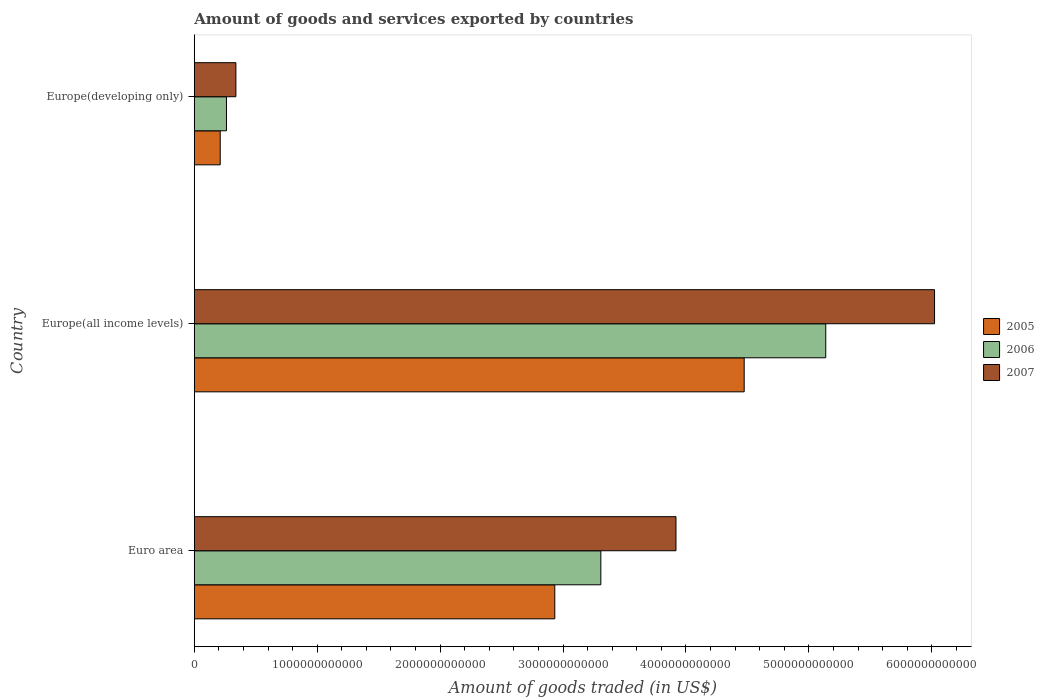How many different coloured bars are there?
Offer a very short reply. 3. In how many cases, is the number of bars for a given country not equal to the number of legend labels?
Offer a very short reply. 0. What is the total amount of goods and services exported in 2005 in Euro area?
Offer a very short reply. 2.93e+12. Across all countries, what is the maximum total amount of goods and services exported in 2006?
Give a very brief answer. 5.14e+12. Across all countries, what is the minimum total amount of goods and services exported in 2007?
Keep it short and to the point. 3.39e+11. In which country was the total amount of goods and services exported in 2007 maximum?
Your response must be concise. Europe(all income levels). In which country was the total amount of goods and services exported in 2005 minimum?
Provide a succinct answer. Europe(developing only). What is the total total amount of goods and services exported in 2007 in the graph?
Give a very brief answer. 1.03e+13. What is the difference between the total amount of goods and services exported in 2005 in Euro area and that in Europe(all income levels)?
Offer a terse response. -1.54e+12. What is the difference between the total amount of goods and services exported in 2006 in Euro area and the total amount of goods and services exported in 2007 in Europe(developing only)?
Your response must be concise. 2.97e+12. What is the average total amount of goods and services exported in 2007 per country?
Offer a very short reply. 3.43e+12. What is the difference between the total amount of goods and services exported in 2006 and total amount of goods and services exported in 2007 in Euro area?
Your response must be concise. -6.11e+11. What is the ratio of the total amount of goods and services exported in 2006 in Euro area to that in Europe(developing only)?
Keep it short and to the point. 12.62. Is the difference between the total amount of goods and services exported in 2006 in Euro area and Europe(developing only) greater than the difference between the total amount of goods and services exported in 2007 in Euro area and Europe(developing only)?
Keep it short and to the point. No. What is the difference between the highest and the second highest total amount of goods and services exported in 2006?
Offer a terse response. 1.83e+12. What is the difference between the highest and the lowest total amount of goods and services exported in 2005?
Your answer should be very brief. 4.26e+12. Is the sum of the total amount of goods and services exported in 2005 in Euro area and Europe(developing only) greater than the maximum total amount of goods and services exported in 2006 across all countries?
Offer a very short reply. No. What does the 3rd bar from the bottom in Euro area represents?
Your answer should be very brief. 2007. Is it the case that in every country, the sum of the total amount of goods and services exported in 2005 and total amount of goods and services exported in 2007 is greater than the total amount of goods and services exported in 2006?
Your answer should be compact. Yes. Are all the bars in the graph horizontal?
Your answer should be compact. Yes. What is the difference between two consecutive major ticks on the X-axis?
Make the answer very short. 1.00e+12. Are the values on the major ticks of X-axis written in scientific E-notation?
Your answer should be very brief. No. Does the graph contain any zero values?
Make the answer very short. No. What is the title of the graph?
Provide a short and direct response. Amount of goods and services exported by countries. What is the label or title of the X-axis?
Keep it short and to the point. Amount of goods traded (in US$). What is the label or title of the Y-axis?
Offer a very short reply. Country. What is the Amount of goods traded (in US$) of 2005 in Euro area?
Your response must be concise. 2.93e+12. What is the Amount of goods traded (in US$) of 2006 in Euro area?
Offer a terse response. 3.31e+12. What is the Amount of goods traded (in US$) of 2007 in Euro area?
Ensure brevity in your answer.  3.92e+12. What is the Amount of goods traded (in US$) of 2005 in Europe(all income levels)?
Ensure brevity in your answer.  4.47e+12. What is the Amount of goods traded (in US$) of 2006 in Europe(all income levels)?
Provide a short and direct response. 5.14e+12. What is the Amount of goods traded (in US$) in 2007 in Europe(all income levels)?
Make the answer very short. 6.02e+12. What is the Amount of goods traded (in US$) in 2005 in Europe(developing only)?
Your answer should be compact. 2.11e+11. What is the Amount of goods traded (in US$) of 2006 in Europe(developing only)?
Keep it short and to the point. 2.62e+11. What is the Amount of goods traded (in US$) of 2007 in Europe(developing only)?
Provide a short and direct response. 3.39e+11. Across all countries, what is the maximum Amount of goods traded (in US$) in 2005?
Make the answer very short. 4.47e+12. Across all countries, what is the maximum Amount of goods traded (in US$) of 2006?
Provide a succinct answer. 5.14e+12. Across all countries, what is the maximum Amount of goods traded (in US$) of 2007?
Your answer should be compact. 6.02e+12. Across all countries, what is the minimum Amount of goods traded (in US$) of 2005?
Your response must be concise. 2.11e+11. Across all countries, what is the minimum Amount of goods traded (in US$) of 2006?
Ensure brevity in your answer.  2.62e+11. Across all countries, what is the minimum Amount of goods traded (in US$) in 2007?
Your answer should be very brief. 3.39e+11. What is the total Amount of goods traded (in US$) of 2005 in the graph?
Provide a succinct answer. 7.62e+12. What is the total Amount of goods traded (in US$) in 2006 in the graph?
Keep it short and to the point. 8.71e+12. What is the total Amount of goods traded (in US$) in 2007 in the graph?
Keep it short and to the point. 1.03e+13. What is the difference between the Amount of goods traded (in US$) in 2005 in Euro area and that in Europe(all income levels)?
Your answer should be compact. -1.54e+12. What is the difference between the Amount of goods traded (in US$) of 2006 in Euro area and that in Europe(all income levels)?
Your answer should be very brief. -1.83e+12. What is the difference between the Amount of goods traded (in US$) of 2007 in Euro area and that in Europe(all income levels)?
Offer a very short reply. -2.10e+12. What is the difference between the Amount of goods traded (in US$) of 2005 in Euro area and that in Europe(developing only)?
Provide a succinct answer. 2.72e+12. What is the difference between the Amount of goods traded (in US$) of 2006 in Euro area and that in Europe(developing only)?
Make the answer very short. 3.05e+12. What is the difference between the Amount of goods traded (in US$) in 2007 in Euro area and that in Europe(developing only)?
Offer a very short reply. 3.58e+12. What is the difference between the Amount of goods traded (in US$) of 2005 in Europe(all income levels) and that in Europe(developing only)?
Offer a terse response. 4.26e+12. What is the difference between the Amount of goods traded (in US$) in 2006 in Europe(all income levels) and that in Europe(developing only)?
Make the answer very short. 4.88e+12. What is the difference between the Amount of goods traded (in US$) of 2007 in Europe(all income levels) and that in Europe(developing only)?
Provide a succinct answer. 5.68e+12. What is the difference between the Amount of goods traded (in US$) of 2005 in Euro area and the Amount of goods traded (in US$) of 2006 in Europe(all income levels)?
Your answer should be very brief. -2.20e+12. What is the difference between the Amount of goods traded (in US$) of 2005 in Euro area and the Amount of goods traded (in US$) of 2007 in Europe(all income levels)?
Provide a succinct answer. -3.09e+12. What is the difference between the Amount of goods traded (in US$) of 2006 in Euro area and the Amount of goods traded (in US$) of 2007 in Europe(all income levels)?
Keep it short and to the point. -2.71e+12. What is the difference between the Amount of goods traded (in US$) in 2005 in Euro area and the Amount of goods traded (in US$) in 2006 in Europe(developing only)?
Ensure brevity in your answer.  2.67e+12. What is the difference between the Amount of goods traded (in US$) of 2005 in Euro area and the Amount of goods traded (in US$) of 2007 in Europe(developing only)?
Ensure brevity in your answer.  2.59e+12. What is the difference between the Amount of goods traded (in US$) in 2006 in Euro area and the Amount of goods traded (in US$) in 2007 in Europe(developing only)?
Ensure brevity in your answer.  2.97e+12. What is the difference between the Amount of goods traded (in US$) of 2005 in Europe(all income levels) and the Amount of goods traded (in US$) of 2006 in Europe(developing only)?
Provide a succinct answer. 4.21e+12. What is the difference between the Amount of goods traded (in US$) of 2005 in Europe(all income levels) and the Amount of goods traded (in US$) of 2007 in Europe(developing only)?
Offer a very short reply. 4.14e+12. What is the difference between the Amount of goods traded (in US$) of 2006 in Europe(all income levels) and the Amount of goods traded (in US$) of 2007 in Europe(developing only)?
Your answer should be compact. 4.80e+12. What is the average Amount of goods traded (in US$) of 2005 per country?
Ensure brevity in your answer.  2.54e+12. What is the average Amount of goods traded (in US$) in 2006 per country?
Your answer should be very brief. 2.90e+12. What is the average Amount of goods traded (in US$) of 2007 per country?
Provide a succinct answer. 3.43e+12. What is the difference between the Amount of goods traded (in US$) in 2005 and Amount of goods traded (in US$) in 2006 in Euro area?
Keep it short and to the point. -3.75e+11. What is the difference between the Amount of goods traded (in US$) of 2005 and Amount of goods traded (in US$) of 2007 in Euro area?
Offer a very short reply. -9.86e+11. What is the difference between the Amount of goods traded (in US$) of 2006 and Amount of goods traded (in US$) of 2007 in Euro area?
Give a very brief answer. -6.11e+11. What is the difference between the Amount of goods traded (in US$) in 2005 and Amount of goods traded (in US$) in 2006 in Europe(all income levels)?
Give a very brief answer. -6.64e+11. What is the difference between the Amount of goods traded (in US$) in 2005 and Amount of goods traded (in US$) in 2007 in Europe(all income levels)?
Your answer should be compact. -1.55e+12. What is the difference between the Amount of goods traded (in US$) in 2006 and Amount of goods traded (in US$) in 2007 in Europe(all income levels)?
Offer a terse response. -8.85e+11. What is the difference between the Amount of goods traded (in US$) of 2005 and Amount of goods traded (in US$) of 2006 in Europe(developing only)?
Your response must be concise. -5.09e+1. What is the difference between the Amount of goods traded (in US$) of 2005 and Amount of goods traded (in US$) of 2007 in Europe(developing only)?
Provide a succinct answer. -1.28e+11. What is the difference between the Amount of goods traded (in US$) of 2006 and Amount of goods traded (in US$) of 2007 in Europe(developing only)?
Give a very brief answer. -7.67e+1. What is the ratio of the Amount of goods traded (in US$) of 2005 in Euro area to that in Europe(all income levels)?
Your answer should be compact. 0.66. What is the ratio of the Amount of goods traded (in US$) in 2006 in Euro area to that in Europe(all income levels)?
Your answer should be very brief. 0.64. What is the ratio of the Amount of goods traded (in US$) of 2007 in Euro area to that in Europe(all income levels)?
Offer a very short reply. 0.65. What is the ratio of the Amount of goods traded (in US$) of 2005 in Euro area to that in Europe(developing only)?
Offer a very short reply. 13.89. What is the ratio of the Amount of goods traded (in US$) of 2006 in Euro area to that in Europe(developing only)?
Keep it short and to the point. 12.62. What is the ratio of the Amount of goods traded (in US$) in 2007 in Euro area to that in Europe(developing only)?
Give a very brief answer. 11.57. What is the ratio of the Amount of goods traded (in US$) in 2005 in Europe(all income levels) to that in Europe(developing only)?
Provide a succinct answer. 21.19. What is the ratio of the Amount of goods traded (in US$) of 2006 in Europe(all income levels) to that in Europe(developing only)?
Your answer should be very brief. 19.61. What is the ratio of the Amount of goods traded (in US$) of 2007 in Europe(all income levels) to that in Europe(developing only)?
Offer a terse response. 17.78. What is the difference between the highest and the second highest Amount of goods traded (in US$) of 2005?
Ensure brevity in your answer.  1.54e+12. What is the difference between the highest and the second highest Amount of goods traded (in US$) in 2006?
Offer a very short reply. 1.83e+12. What is the difference between the highest and the second highest Amount of goods traded (in US$) in 2007?
Make the answer very short. 2.10e+12. What is the difference between the highest and the lowest Amount of goods traded (in US$) in 2005?
Provide a succinct answer. 4.26e+12. What is the difference between the highest and the lowest Amount of goods traded (in US$) in 2006?
Provide a short and direct response. 4.88e+12. What is the difference between the highest and the lowest Amount of goods traded (in US$) in 2007?
Make the answer very short. 5.68e+12. 